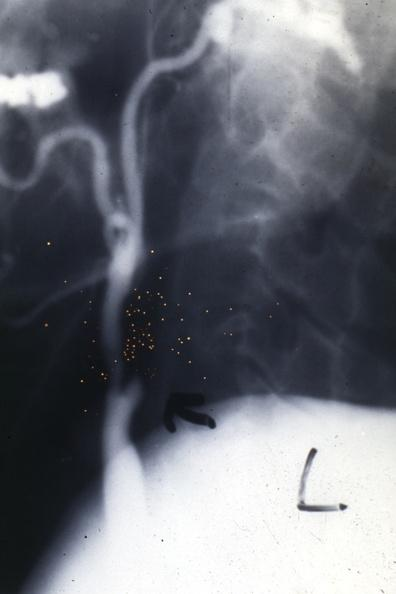what is present?
Answer the question using a single word or phrase. Cardiovascular 